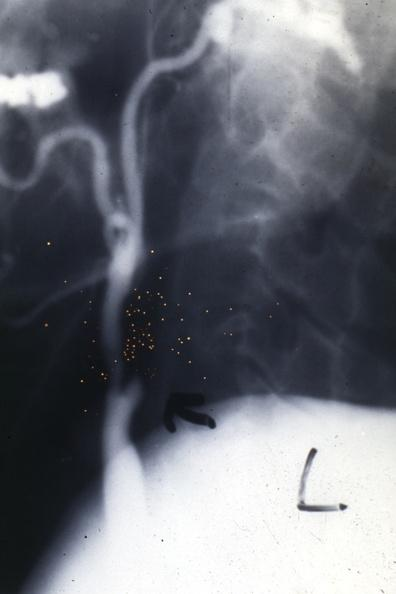what is present?
Answer the question using a single word or phrase. Cardiovascular 